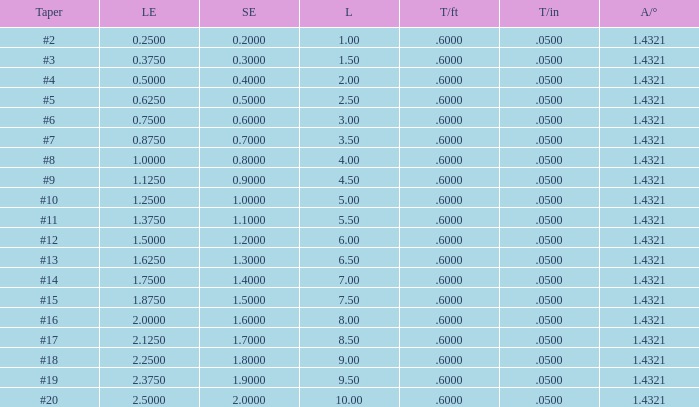Which Taper/in that has a Small end larger than 0.7000000000000001, and a Taper of #19, and a Large end larger than 2.375? None. 